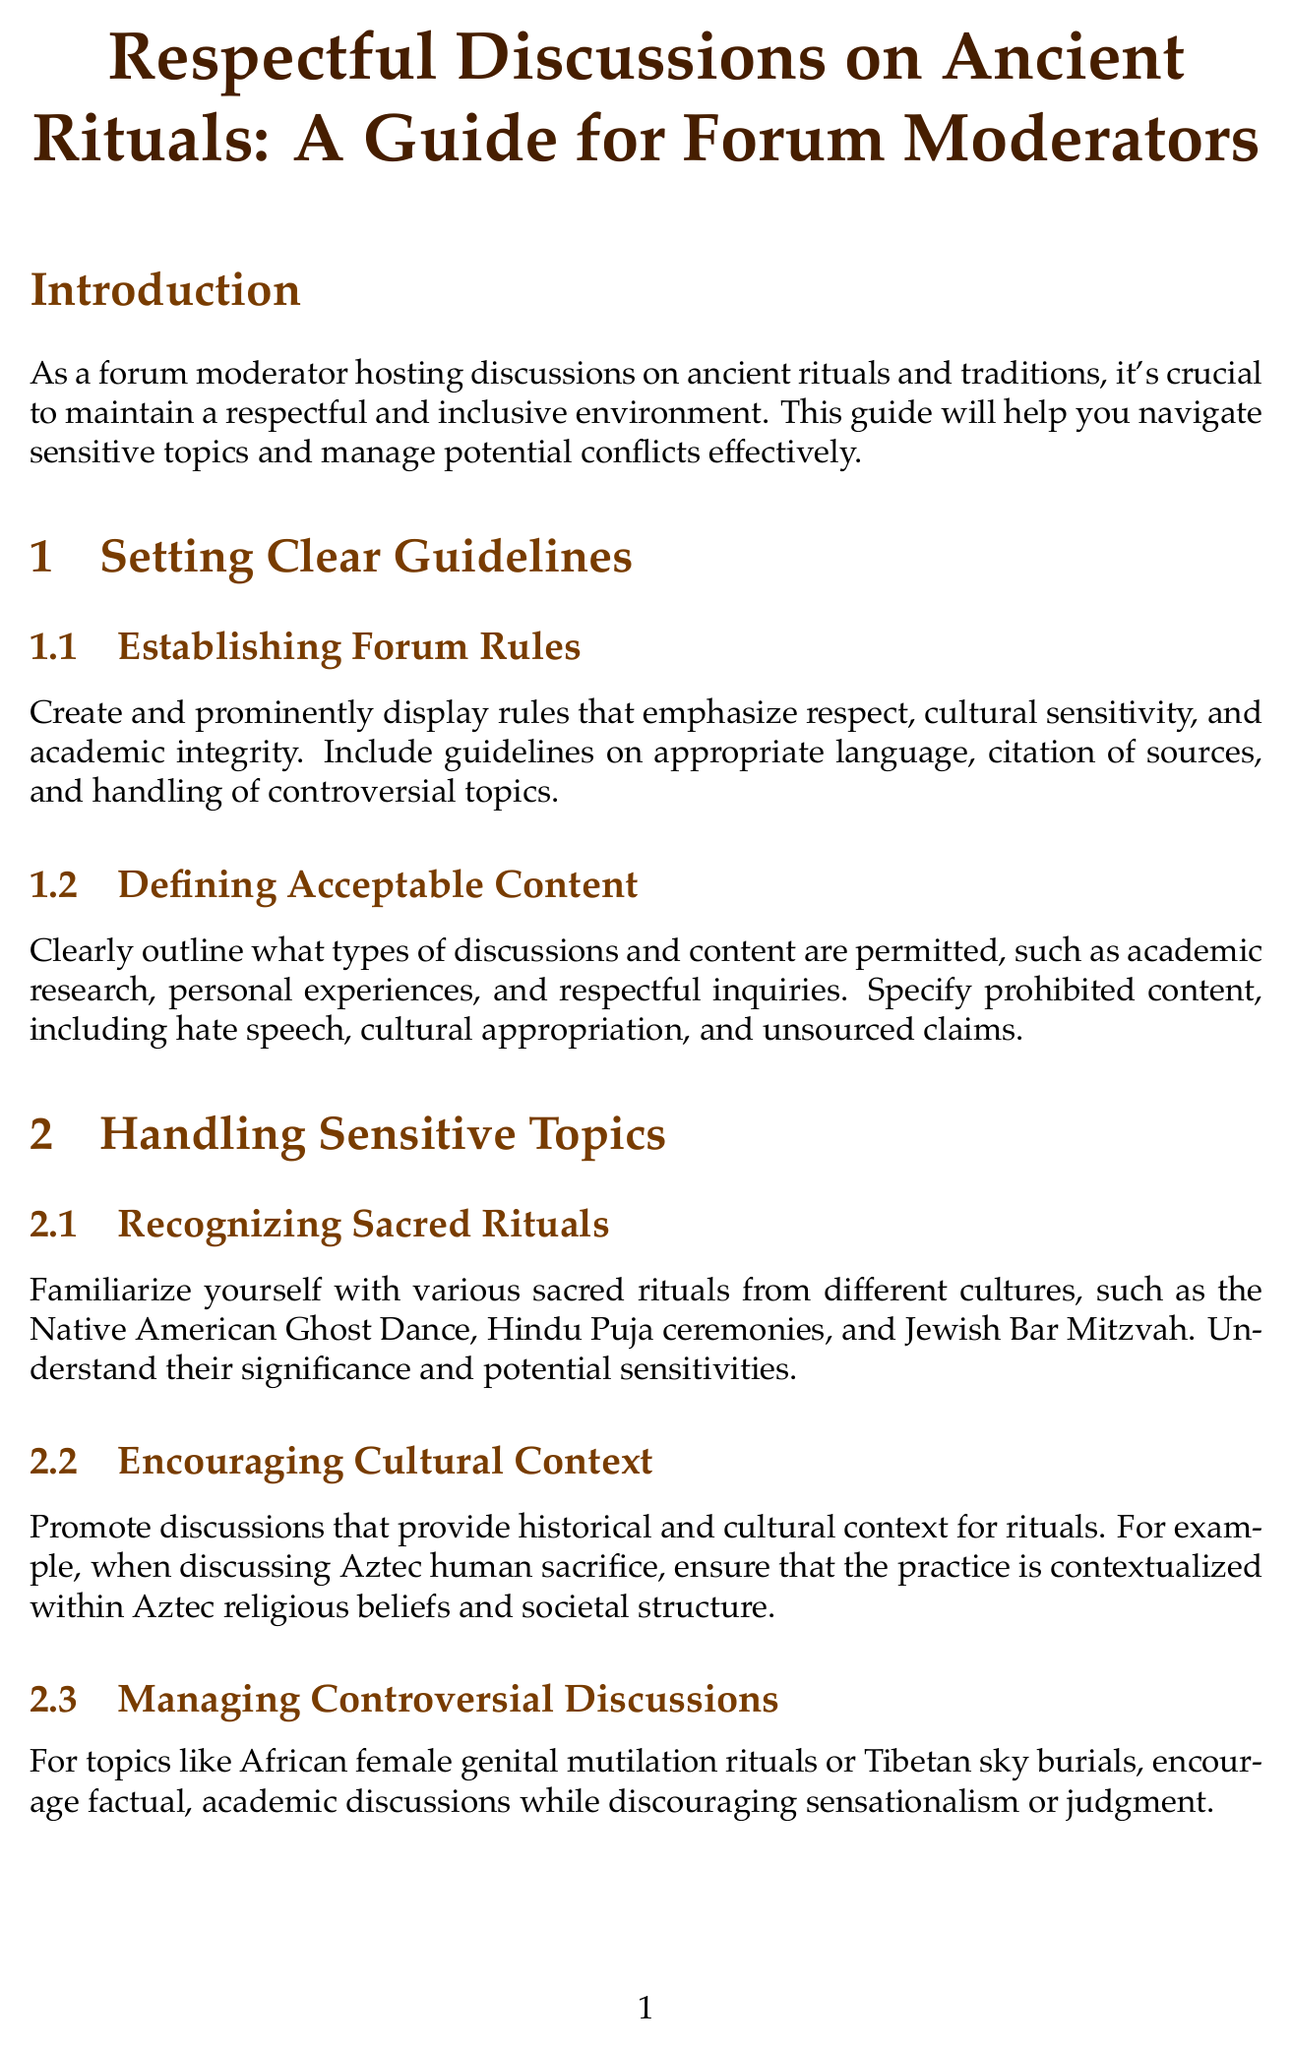What is the title of the manual? The title of the manual is presented in the header of the document and serves as the main subject of the content.
Answer: Respectful Discussions on Ancient Rituals: A Guide for Forum Moderators What section discusses de-escalation techniques? The section that addresses de-escalation techniques is part of the conflict resolution strategies and provides specific guidance on roles within discussions.
Answer: Conflict Resolution Strategies How many subsections are in the "Promoting Diverse Perspectives" section? The number of subsections can be counted based on the content organized under that main section heading.
Answer: 2 What type of contributions should be encouraged according to the guide? The guide emphasizes seeking contributions from specific expert groups to enrich discussions about rituals, reflecting a broader understanding.
Answer: Expert Contributions What is the recommended action for addressing cultural insensitivity? The document suggests having a protocol, outlining steps to manage inappropriate behavior in an effective manner.
Answer: Private messages, public clarifications, or temporary bans What is one of the resources recommended for reliable information on ancient rituals? The document suggests a specific academic journal that is recognized for its scholarly contributions related to the subject.
Answer: Journal of Ritual Studies What kind of feedback should forum moderators seek? The document emphasizes the importance of feedback to enhance the moderation process and improve discussion quality.
Answer: Anonymous surveys or dedicated feedback threads What should discussions about Aztec human sacrifice include? The guide specifies a crucial aspect that must accompany discussions about sensitive cultural topics to ensure respectful communication.
Answer: Historical and cultural context What strategy is suggested for guiding heated discussions? The document provides insight into an approach that utilizes emotional awareness and communication techniques to manage conflicts effectively.
Answer: De-escalation techniques 